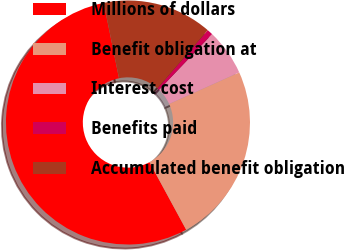<chart> <loc_0><loc_0><loc_500><loc_500><pie_chart><fcel>Millions of dollars<fcel>Benefit obligation at<fcel>Interest cost<fcel>Benefits paid<fcel>Accumulated benefit obligation<nl><fcel>54.73%<fcel>23.82%<fcel>6.16%<fcel>0.76%<fcel>14.53%<nl></chart> 